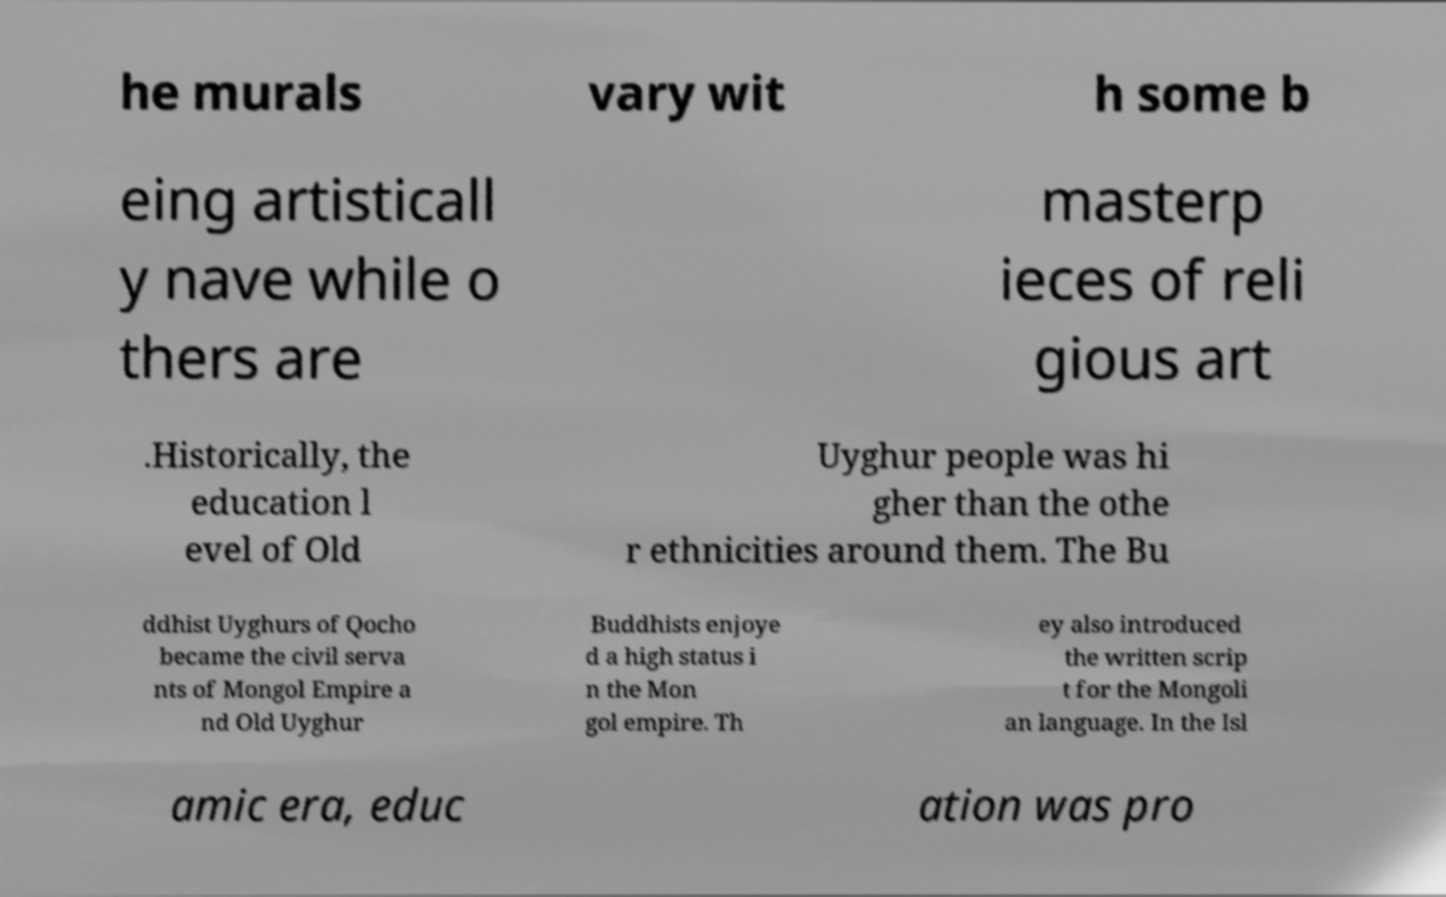Could you assist in decoding the text presented in this image and type it out clearly? he murals vary wit h some b eing artisticall y nave while o thers are masterp ieces of reli gious art .Historically, the education l evel of Old Uyghur people was hi gher than the othe r ethnicities around them. The Bu ddhist Uyghurs of Qocho became the civil serva nts of Mongol Empire a nd Old Uyghur Buddhists enjoye d a high status i n the Mon gol empire. Th ey also introduced the written scrip t for the Mongoli an language. In the Isl amic era, educ ation was pro 